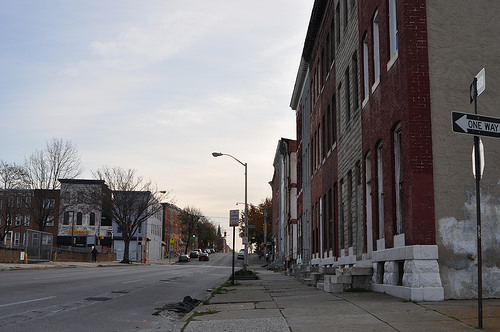<image>
Is there a pole on the tree? No. The pole is not positioned on the tree. They may be near each other, but the pole is not supported by or resting on top of the tree. 